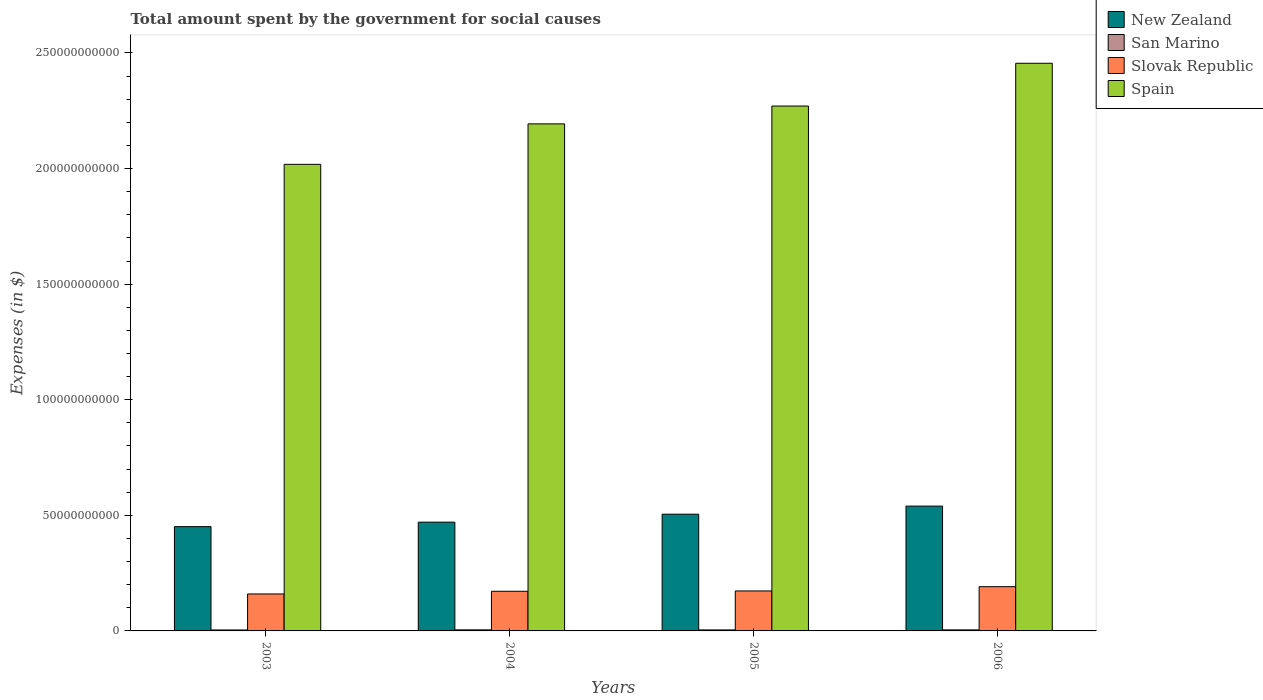How many groups of bars are there?
Your answer should be compact. 4. How many bars are there on the 4th tick from the right?
Keep it short and to the point. 4. What is the label of the 4th group of bars from the left?
Your answer should be compact. 2006. In how many cases, is the number of bars for a given year not equal to the number of legend labels?
Give a very brief answer. 0. What is the amount spent for social causes by the government in San Marino in 2005?
Your answer should be very brief. 4.33e+08. Across all years, what is the maximum amount spent for social causes by the government in San Marino?
Provide a short and direct response. 4.59e+08. Across all years, what is the minimum amount spent for social causes by the government in Spain?
Give a very brief answer. 2.02e+11. In which year was the amount spent for social causes by the government in Slovak Republic maximum?
Keep it short and to the point. 2006. In which year was the amount spent for social causes by the government in Spain minimum?
Your answer should be compact. 2003. What is the total amount spent for social causes by the government in New Zealand in the graph?
Provide a succinct answer. 1.97e+11. What is the difference between the amount spent for social causes by the government in Spain in 2004 and that in 2005?
Offer a very short reply. -7.71e+09. What is the difference between the amount spent for social causes by the government in New Zealand in 2005 and the amount spent for social causes by the government in San Marino in 2006?
Your answer should be very brief. 5.00e+1. What is the average amount spent for social causes by the government in San Marino per year?
Offer a terse response. 4.36e+08. In the year 2004, what is the difference between the amount spent for social causes by the government in San Marino and amount spent for social causes by the government in Spain?
Offer a very short reply. -2.19e+11. What is the ratio of the amount spent for social causes by the government in San Marino in 2005 to that in 2006?
Offer a very short reply. 0.97. Is the difference between the amount spent for social causes by the government in San Marino in 2005 and 2006 greater than the difference between the amount spent for social causes by the government in Spain in 2005 and 2006?
Keep it short and to the point. Yes. What is the difference between the highest and the second highest amount spent for social causes by the government in San Marino?
Make the answer very short. 1.31e+07. What is the difference between the highest and the lowest amount spent for social causes by the government in San Marino?
Your response must be concise. 5.16e+07. Is the sum of the amount spent for social causes by the government in Spain in 2004 and 2006 greater than the maximum amount spent for social causes by the government in Slovak Republic across all years?
Make the answer very short. Yes. What does the 2nd bar from the left in 2005 represents?
Keep it short and to the point. San Marino. What does the 3rd bar from the right in 2004 represents?
Provide a short and direct response. San Marino. Is it the case that in every year, the sum of the amount spent for social causes by the government in Spain and amount spent for social causes by the government in Slovak Republic is greater than the amount spent for social causes by the government in New Zealand?
Offer a very short reply. Yes. How many bars are there?
Provide a succinct answer. 16. What is the difference between two consecutive major ticks on the Y-axis?
Your answer should be very brief. 5.00e+1. Are the values on the major ticks of Y-axis written in scientific E-notation?
Your answer should be very brief. No. Does the graph contain any zero values?
Your answer should be very brief. No. Does the graph contain grids?
Your answer should be compact. No. Where does the legend appear in the graph?
Provide a succinct answer. Top right. What is the title of the graph?
Your answer should be compact. Total amount spent by the government for social causes. What is the label or title of the Y-axis?
Give a very brief answer. Expenses (in $). What is the Expenses (in $) of New Zealand in 2003?
Your answer should be very brief. 4.51e+1. What is the Expenses (in $) in San Marino in 2003?
Your answer should be very brief. 4.07e+08. What is the Expenses (in $) in Slovak Republic in 2003?
Keep it short and to the point. 1.60e+1. What is the Expenses (in $) of Spain in 2003?
Give a very brief answer. 2.02e+11. What is the Expenses (in $) in New Zealand in 2004?
Give a very brief answer. 4.70e+1. What is the Expenses (in $) of San Marino in 2004?
Your answer should be very brief. 4.59e+08. What is the Expenses (in $) in Slovak Republic in 2004?
Ensure brevity in your answer.  1.71e+1. What is the Expenses (in $) of Spain in 2004?
Your answer should be compact. 2.19e+11. What is the Expenses (in $) of New Zealand in 2005?
Your response must be concise. 5.05e+1. What is the Expenses (in $) of San Marino in 2005?
Your response must be concise. 4.33e+08. What is the Expenses (in $) of Slovak Republic in 2005?
Your answer should be very brief. 1.73e+1. What is the Expenses (in $) in Spain in 2005?
Your answer should be compact. 2.27e+11. What is the Expenses (in $) in New Zealand in 2006?
Make the answer very short. 5.40e+1. What is the Expenses (in $) of San Marino in 2006?
Provide a short and direct response. 4.46e+08. What is the Expenses (in $) in Slovak Republic in 2006?
Your answer should be very brief. 1.91e+1. What is the Expenses (in $) in Spain in 2006?
Make the answer very short. 2.46e+11. Across all years, what is the maximum Expenses (in $) in New Zealand?
Your answer should be very brief. 5.40e+1. Across all years, what is the maximum Expenses (in $) in San Marino?
Give a very brief answer. 4.59e+08. Across all years, what is the maximum Expenses (in $) in Slovak Republic?
Your answer should be very brief. 1.91e+1. Across all years, what is the maximum Expenses (in $) in Spain?
Your response must be concise. 2.46e+11. Across all years, what is the minimum Expenses (in $) of New Zealand?
Ensure brevity in your answer.  4.51e+1. Across all years, what is the minimum Expenses (in $) of San Marino?
Offer a terse response. 4.07e+08. Across all years, what is the minimum Expenses (in $) of Slovak Republic?
Keep it short and to the point. 1.60e+1. Across all years, what is the minimum Expenses (in $) in Spain?
Your answer should be very brief. 2.02e+11. What is the total Expenses (in $) of New Zealand in the graph?
Offer a very short reply. 1.97e+11. What is the total Expenses (in $) in San Marino in the graph?
Your response must be concise. 1.74e+09. What is the total Expenses (in $) in Slovak Republic in the graph?
Your answer should be compact. 6.96e+1. What is the total Expenses (in $) of Spain in the graph?
Offer a terse response. 8.94e+11. What is the difference between the Expenses (in $) in New Zealand in 2003 and that in 2004?
Your response must be concise. -1.93e+09. What is the difference between the Expenses (in $) in San Marino in 2003 and that in 2004?
Keep it short and to the point. -5.16e+07. What is the difference between the Expenses (in $) in Slovak Republic in 2003 and that in 2004?
Keep it short and to the point. -1.16e+09. What is the difference between the Expenses (in $) of Spain in 2003 and that in 2004?
Provide a short and direct response. -1.75e+1. What is the difference between the Expenses (in $) in New Zealand in 2003 and that in 2005?
Keep it short and to the point. -5.38e+09. What is the difference between the Expenses (in $) in San Marino in 2003 and that in 2005?
Offer a very short reply. -2.59e+07. What is the difference between the Expenses (in $) in Slovak Republic in 2003 and that in 2005?
Your answer should be compact. -1.31e+09. What is the difference between the Expenses (in $) of Spain in 2003 and that in 2005?
Ensure brevity in your answer.  -2.52e+1. What is the difference between the Expenses (in $) in New Zealand in 2003 and that in 2006?
Your answer should be very brief. -8.87e+09. What is the difference between the Expenses (in $) in San Marino in 2003 and that in 2006?
Your answer should be very brief. -3.85e+07. What is the difference between the Expenses (in $) in Slovak Republic in 2003 and that in 2006?
Keep it short and to the point. -3.15e+09. What is the difference between the Expenses (in $) in Spain in 2003 and that in 2006?
Your answer should be compact. -4.37e+1. What is the difference between the Expenses (in $) of New Zealand in 2004 and that in 2005?
Your answer should be very brief. -3.44e+09. What is the difference between the Expenses (in $) of San Marino in 2004 and that in 2005?
Keep it short and to the point. 2.57e+07. What is the difference between the Expenses (in $) of Slovak Republic in 2004 and that in 2005?
Provide a short and direct response. -1.47e+08. What is the difference between the Expenses (in $) of Spain in 2004 and that in 2005?
Give a very brief answer. -7.71e+09. What is the difference between the Expenses (in $) of New Zealand in 2004 and that in 2006?
Keep it short and to the point. -6.94e+09. What is the difference between the Expenses (in $) of San Marino in 2004 and that in 2006?
Give a very brief answer. 1.31e+07. What is the difference between the Expenses (in $) of Slovak Republic in 2004 and that in 2006?
Give a very brief answer. -1.99e+09. What is the difference between the Expenses (in $) in Spain in 2004 and that in 2006?
Provide a succinct answer. -2.62e+1. What is the difference between the Expenses (in $) of New Zealand in 2005 and that in 2006?
Provide a succinct answer. -3.50e+09. What is the difference between the Expenses (in $) of San Marino in 2005 and that in 2006?
Ensure brevity in your answer.  -1.26e+07. What is the difference between the Expenses (in $) in Slovak Republic in 2005 and that in 2006?
Your answer should be compact. -1.84e+09. What is the difference between the Expenses (in $) of Spain in 2005 and that in 2006?
Your answer should be compact. -1.85e+1. What is the difference between the Expenses (in $) of New Zealand in 2003 and the Expenses (in $) of San Marino in 2004?
Offer a very short reply. 4.47e+1. What is the difference between the Expenses (in $) of New Zealand in 2003 and the Expenses (in $) of Slovak Republic in 2004?
Offer a very short reply. 2.80e+1. What is the difference between the Expenses (in $) in New Zealand in 2003 and the Expenses (in $) in Spain in 2004?
Ensure brevity in your answer.  -1.74e+11. What is the difference between the Expenses (in $) of San Marino in 2003 and the Expenses (in $) of Slovak Republic in 2004?
Make the answer very short. -1.67e+1. What is the difference between the Expenses (in $) in San Marino in 2003 and the Expenses (in $) in Spain in 2004?
Offer a very short reply. -2.19e+11. What is the difference between the Expenses (in $) of Slovak Republic in 2003 and the Expenses (in $) of Spain in 2004?
Provide a short and direct response. -2.03e+11. What is the difference between the Expenses (in $) of New Zealand in 2003 and the Expenses (in $) of San Marino in 2005?
Your answer should be compact. 4.47e+1. What is the difference between the Expenses (in $) of New Zealand in 2003 and the Expenses (in $) of Slovak Republic in 2005?
Your answer should be compact. 2.78e+1. What is the difference between the Expenses (in $) of New Zealand in 2003 and the Expenses (in $) of Spain in 2005?
Your answer should be compact. -1.82e+11. What is the difference between the Expenses (in $) of San Marino in 2003 and the Expenses (in $) of Slovak Republic in 2005?
Offer a terse response. -1.69e+1. What is the difference between the Expenses (in $) of San Marino in 2003 and the Expenses (in $) of Spain in 2005?
Ensure brevity in your answer.  -2.27e+11. What is the difference between the Expenses (in $) of Slovak Republic in 2003 and the Expenses (in $) of Spain in 2005?
Keep it short and to the point. -2.11e+11. What is the difference between the Expenses (in $) of New Zealand in 2003 and the Expenses (in $) of San Marino in 2006?
Offer a terse response. 4.47e+1. What is the difference between the Expenses (in $) of New Zealand in 2003 and the Expenses (in $) of Slovak Republic in 2006?
Offer a very short reply. 2.60e+1. What is the difference between the Expenses (in $) in New Zealand in 2003 and the Expenses (in $) in Spain in 2006?
Offer a very short reply. -2.00e+11. What is the difference between the Expenses (in $) of San Marino in 2003 and the Expenses (in $) of Slovak Republic in 2006?
Offer a very short reply. -1.87e+1. What is the difference between the Expenses (in $) of San Marino in 2003 and the Expenses (in $) of Spain in 2006?
Offer a very short reply. -2.45e+11. What is the difference between the Expenses (in $) of Slovak Republic in 2003 and the Expenses (in $) of Spain in 2006?
Your response must be concise. -2.30e+11. What is the difference between the Expenses (in $) of New Zealand in 2004 and the Expenses (in $) of San Marino in 2005?
Keep it short and to the point. 4.66e+1. What is the difference between the Expenses (in $) of New Zealand in 2004 and the Expenses (in $) of Slovak Republic in 2005?
Offer a terse response. 2.97e+1. What is the difference between the Expenses (in $) of New Zealand in 2004 and the Expenses (in $) of Spain in 2005?
Your answer should be very brief. -1.80e+11. What is the difference between the Expenses (in $) of San Marino in 2004 and the Expenses (in $) of Slovak Republic in 2005?
Your answer should be compact. -1.68e+1. What is the difference between the Expenses (in $) in San Marino in 2004 and the Expenses (in $) in Spain in 2005?
Your answer should be very brief. -2.27e+11. What is the difference between the Expenses (in $) in Slovak Republic in 2004 and the Expenses (in $) in Spain in 2005?
Provide a short and direct response. -2.10e+11. What is the difference between the Expenses (in $) of New Zealand in 2004 and the Expenses (in $) of San Marino in 2006?
Keep it short and to the point. 4.66e+1. What is the difference between the Expenses (in $) of New Zealand in 2004 and the Expenses (in $) of Slovak Republic in 2006?
Your answer should be very brief. 2.79e+1. What is the difference between the Expenses (in $) of New Zealand in 2004 and the Expenses (in $) of Spain in 2006?
Offer a terse response. -1.98e+11. What is the difference between the Expenses (in $) of San Marino in 2004 and the Expenses (in $) of Slovak Republic in 2006?
Keep it short and to the point. -1.87e+1. What is the difference between the Expenses (in $) in San Marino in 2004 and the Expenses (in $) in Spain in 2006?
Ensure brevity in your answer.  -2.45e+11. What is the difference between the Expenses (in $) of Slovak Republic in 2004 and the Expenses (in $) of Spain in 2006?
Your response must be concise. -2.28e+11. What is the difference between the Expenses (in $) of New Zealand in 2005 and the Expenses (in $) of San Marino in 2006?
Your response must be concise. 5.00e+1. What is the difference between the Expenses (in $) of New Zealand in 2005 and the Expenses (in $) of Slovak Republic in 2006?
Provide a succinct answer. 3.13e+1. What is the difference between the Expenses (in $) in New Zealand in 2005 and the Expenses (in $) in Spain in 2006?
Your answer should be compact. -1.95e+11. What is the difference between the Expenses (in $) of San Marino in 2005 and the Expenses (in $) of Slovak Republic in 2006?
Provide a succinct answer. -1.87e+1. What is the difference between the Expenses (in $) in San Marino in 2005 and the Expenses (in $) in Spain in 2006?
Your answer should be compact. -2.45e+11. What is the difference between the Expenses (in $) in Slovak Republic in 2005 and the Expenses (in $) in Spain in 2006?
Give a very brief answer. -2.28e+11. What is the average Expenses (in $) in New Zealand per year?
Provide a succinct answer. 4.92e+1. What is the average Expenses (in $) of San Marino per year?
Your answer should be compact. 4.36e+08. What is the average Expenses (in $) in Slovak Republic per year?
Offer a very short reply. 1.74e+1. What is the average Expenses (in $) of Spain per year?
Keep it short and to the point. 2.23e+11. In the year 2003, what is the difference between the Expenses (in $) of New Zealand and Expenses (in $) of San Marino?
Provide a succinct answer. 4.47e+1. In the year 2003, what is the difference between the Expenses (in $) in New Zealand and Expenses (in $) in Slovak Republic?
Ensure brevity in your answer.  2.91e+1. In the year 2003, what is the difference between the Expenses (in $) of New Zealand and Expenses (in $) of Spain?
Ensure brevity in your answer.  -1.57e+11. In the year 2003, what is the difference between the Expenses (in $) of San Marino and Expenses (in $) of Slovak Republic?
Your response must be concise. -1.56e+1. In the year 2003, what is the difference between the Expenses (in $) of San Marino and Expenses (in $) of Spain?
Offer a terse response. -2.01e+11. In the year 2003, what is the difference between the Expenses (in $) of Slovak Republic and Expenses (in $) of Spain?
Provide a short and direct response. -1.86e+11. In the year 2004, what is the difference between the Expenses (in $) in New Zealand and Expenses (in $) in San Marino?
Provide a succinct answer. 4.66e+1. In the year 2004, what is the difference between the Expenses (in $) of New Zealand and Expenses (in $) of Slovak Republic?
Offer a terse response. 2.99e+1. In the year 2004, what is the difference between the Expenses (in $) in New Zealand and Expenses (in $) in Spain?
Your answer should be very brief. -1.72e+11. In the year 2004, what is the difference between the Expenses (in $) in San Marino and Expenses (in $) in Slovak Republic?
Your answer should be compact. -1.67e+1. In the year 2004, what is the difference between the Expenses (in $) in San Marino and Expenses (in $) in Spain?
Provide a succinct answer. -2.19e+11. In the year 2004, what is the difference between the Expenses (in $) of Slovak Republic and Expenses (in $) of Spain?
Provide a short and direct response. -2.02e+11. In the year 2005, what is the difference between the Expenses (in $) in New Zealand and Expenses (in $) in San Marino?
Keep it short and to the point. 5.01e+1. In the year 2005, what is the difference between the Expenses (in $) of New Zealand and Expenses (in $) of Slovak Republic?
Your answer should be compact. 3.32e+1. In the year 2005, what is the difference between the Expenses (in $) in New Zealand and Expenses (in $) in Spain?
Keep it short and to the point. -1.77e+11. In the year 2005, what is the difference between the Expenses (in $) of San Marino and Expenses (in $) of Slovak Republic?
Your answer should be very brief. -1.69e+1. In the year 2005, what is the difference between the Expenses (in $) of San Marino and Expenses (in $) of Spain?
Your response must be concise. -2.27e+11. In the year 2005, what is the difference between the Expenses (in $) in Slovak Republic and Expenses (in $) in Spain?
Offer a terse response. -2.10e+11. In the year 2006, what is the difference between the Expenses (in $) in New Zealand and Expenses (in $) in San Marino?
Make the answer very short. 5.35e+1. In the year 2006, what is the difference between the Expenses (in $) of New Zealand and Expenses (in $) of Slovak Republic?
Give a very brief answer. 3.48e+1. In the year 2006, what is the difference between the Expenses (in $) of New Zealand and Expenses (in $) of Spain?
Ensure brevity in your answer.  -1.92e+11. In the year 2006, what is the difference between the Expenses (in $) in San Marino and Expenses (in $) in Slovak Republic?
Provide a succinct answer. -1.87e+1. In the year 2006, what is the difference between the Expenses (in $) of San Marino and Expenses (in $) of Spain?
Offer a terse response. -2.45e+11. In the year 2006, what is the difference between the Expenses (in $) in Slovak Republic and Expenses (in $) in Spain?
Keep it short and to the point. -2.26e+11. What is the ratio of the Expenses (in $) in New Zealand in 2003 to that in 2004?
Offer a very short reply. 0.96. What is the ratio of the Expenses (in $) in San Marino in 2003 to that in 2004?
Provide a succinct answer. 0.89. What is the ratio of the Expenses (in $) in Slovak Republic in 2003 to that in 2004?
Ensure brevity in your answer.  0.93. What is the ratio of the Expenses (in $) in Spain in 2003 to that in 2004?
Provide a succinct answer. 0.92. What is the ratio of the Expenses (in $) of New Zealand in 2003 to that in 2005?
Keep it short and to the point. 0.89. What is the ratio of the Expenses (in $) of San Marino in 2003 to that in 2005?
Keep it short and to the point. 0.94. What is the ratio of the Expenses (in $) in Slovak Republic in 2003 to that in 2005?
Provide a short and direct response. 0.92. What is the ratio of the Expenses (in $) in Spain in 2003 to that in 2005?
Your answer should be very brief. 0.89. What is the ratio of the Expenses (in $) in New Zealand in 2003 to that in 2006?
Give a very brief answer. 0.84. What is the ratio of the Expenses (in $) of San Marino in 2003 to that in 2006?
Your answer should be very brief. 0.91. What is the ratio of the Expenses (in $) of Slovak Republic in 2003 to that in 2006?
Your answer should be compact. 0.84. What is the ratio of the Expenses (in $) of Spain in 2003 to that in 2006?
Provide a succinct answer. 0.82. What is the ratio of the Expenses (in $) in New Zealand in 2004 to that in 2005?
Make the answer very short. 0.93. What is the ratio of the Expenses (in $) of San Marino in 2004 to that in 2005?
Make the answer very short. 1.06. What is the ratio of the Expenses (in $) in Slovak Republic in 2004 to that in 2005?
Provide a short and direct response. 0.99. What is the ratio of the Expenses (in $) in Spain in 2004 to that in 2005?
Ensure brevity in your answer.  0.97. What is the ratio of the Expenses (in $) of New Zealand in 2004 to that in 2006?
Keep it short and to the point. 0.87. What is the ratio of the Expenses (in $) of San Marino in 2004 to that in 2006?
Ensure brevity in your answer.  1.03. What is the ratio of the Expenses (in $) in Slovak Republic in 2004 to that in 2006?
Your response must be concise. 0.9. What is the ratio of the Expenses (in $) of Spain in 2004 to that in 2006?
Make the answer very short. 0.89. What is the ratio of the Expenses (in $) in New Zealand in 2005 to that in 2006?
Provide a succinct answer. 0.94. What is the ratio of the Expenses (in $) in San Marino in 2005 to that in 2006?
Offer a very short reply. 0.97. What is the ratio of the Expenses (in $) of Slovak Republic in 2005 to that in 2006?
Provide a succinct answer. 0.9. What is the ratio of the Expenses (in $) in Spain in 2005 to that in 2006?
Give a very brief answer. 0.92. What is the difference between the highest and the second highest Expenses (in $) of New Zealand?
Make the answer very short. 3.50e+09. What is the difference between the highest and the second highest Expenses (in $) in San Marino?
Provide a short and direct response. 1.31e+07. What is the difference between the highest and the second highest Expenses (in $) of Slovak Republic?
Offer a terse response. 1.84e+09. What is the difference between the highest and the second highest Expenses (in $) in Spain?
Your response must be concise. 1.85e+1. What is the difference between the highest and the lowest Expenses (in $) of New Zealand?
Make the answer very short. 8.87e+09. What is the difference between the highest and the lowest Expenses (in $) of San Marino?
Ensure brevity in your answer.  5.16e+07. What is the difference between the highest and the lowest Expenses (in $) of Slovak Republic?
Ensure brevity in your answer.  3.15e+09. What is the difference between the highest and the lowest Expenses (in $) of Spain?
Offer a terse response. 4.37e+1. 